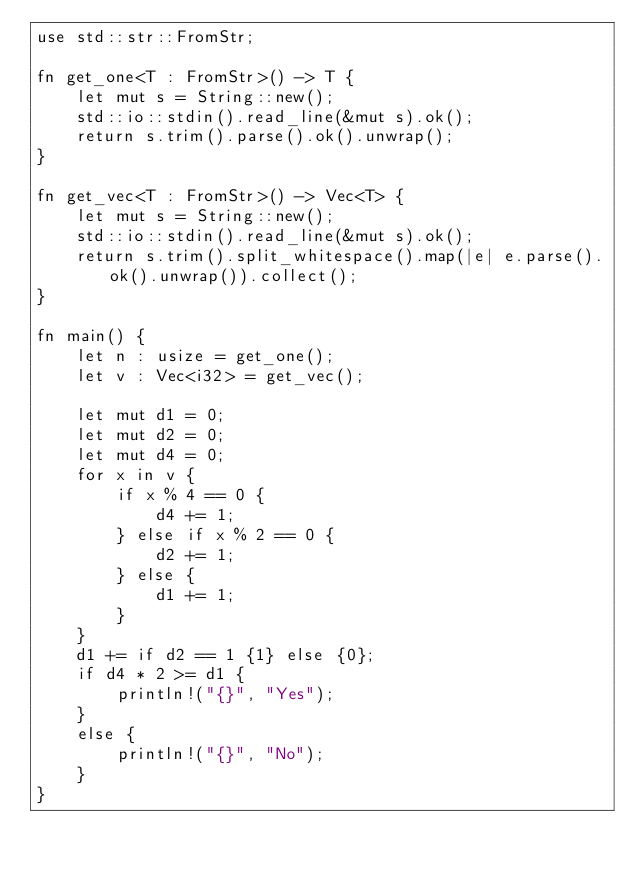<code> <loc_0><loc_0><loc_500><loc_500><_Rust_>use std::str::FromStr;

fn get_one<T : FromStr>() -> T {
    let mut s = String::new();
    std::io::stdin().read_line(&mut s).ok();
    return s.trim().parse().ok().unwrap();
}

fn get_vec<T : FromStr>() -> Vec<T> {
    let mut s = String::new();
    std::io::stdin().read_line(&mut s).ok();
    return s.trim().split_whitespace().map(|e| e.parse().ok().unwrap()).collect();
}

fn main() {
    let n : usize = get_one();
    let v : Vec<i32> = get_vec();

    let mut d1 = 0;
    let mut d2 = 0;
    let mut d4 = 0;
    for x in v {
        if x % 4 == 0 {
            d4 += 1;
        } else if x % 2 == 0 {
            d2 += 1;
        } else {
            d1 += 1;
        }
    }
    d1 += if d2 == 1 {1} else {0};
    if d4 * 2 >= d1 {
        println!("{}", "Yes");
    }
    else {
        println!("{}", "No");
    }
}
</code> 